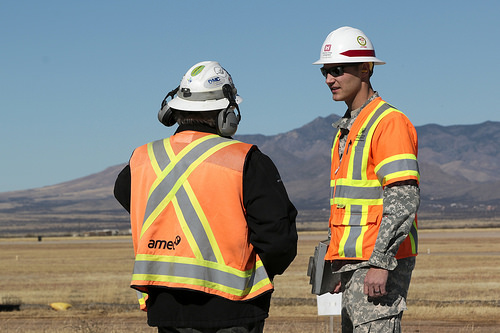<image>
Is there a man on the mountains? No. The man is not positioned on the mountains. They may be near each other, but the man is not supported by or resting on top of the mountains. Where is the man in relation to the man? Is it next to the man? Yes. The man is positioned adjacent to the man, located nearby in the same general area. 